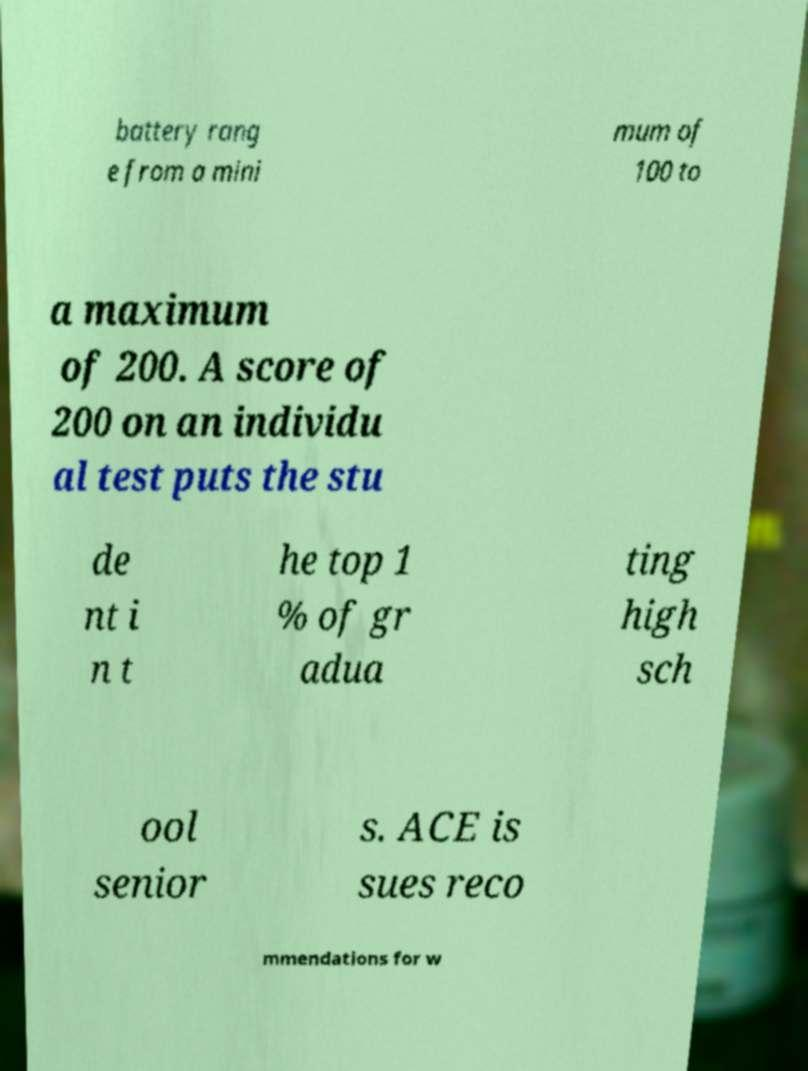I need the written content from this picture converted into text. Can you do that? battery rang e from a mini mum of 100 to a maximum of 200. A score of 200 on an individu al test puts the stu de nt i n t he top 1 % of gr adua ting high sch ool senior s. ACE is sues reco mmendations for w 